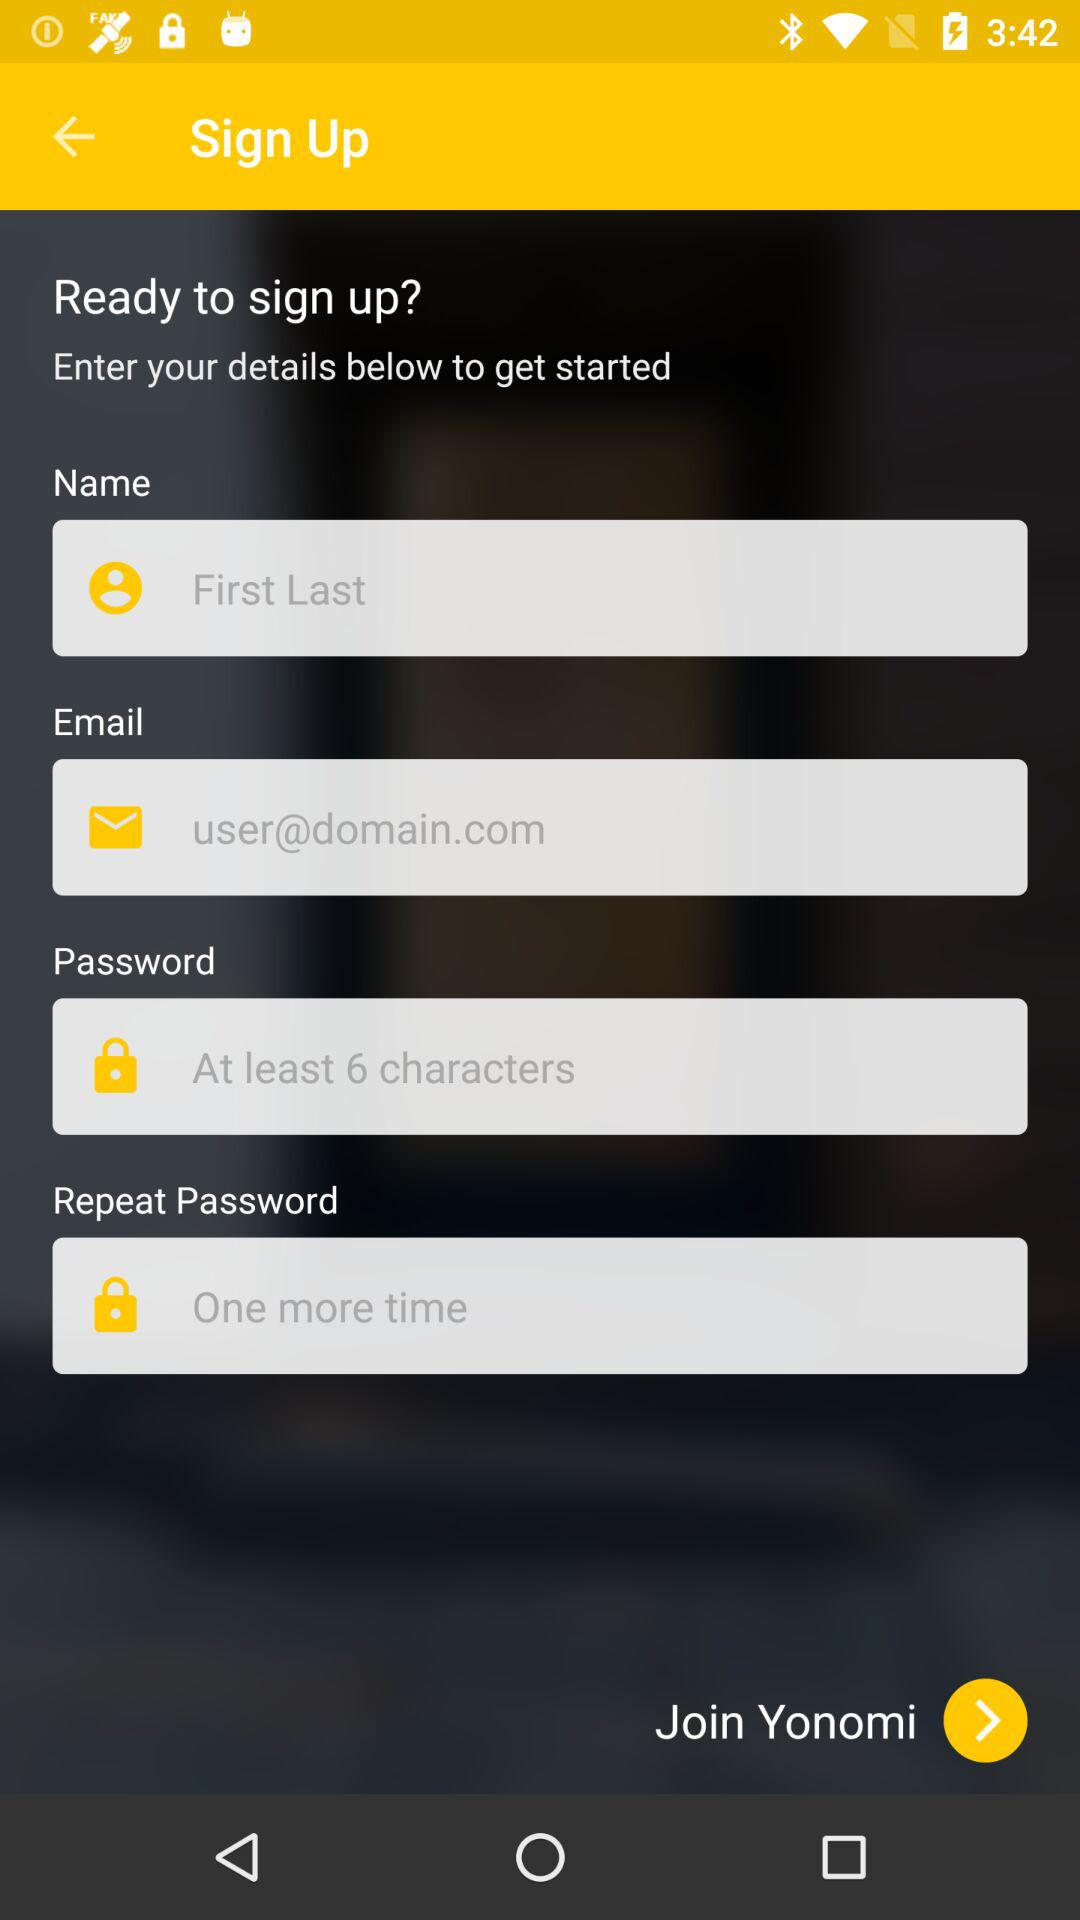What is the email address?
When the provided information is insufficient, respond with <no answer>. <no answer> 